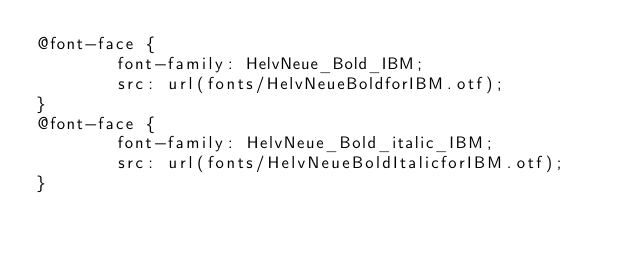Convert code to text. <code><loc_0><loc_0><loc_500><loc_500><_CSS_>@font-face {
        font-family: HelvNeue_Bold_IBM;
        src: url(fonts/HelvNeueBoldforIBM.otf);
}
@font-face {
        font-family: HelvNeue_Bold_italic_IBM;
        src: url(fonts/HelvNeueBoldItalicforIBM.otf);
}</code> 